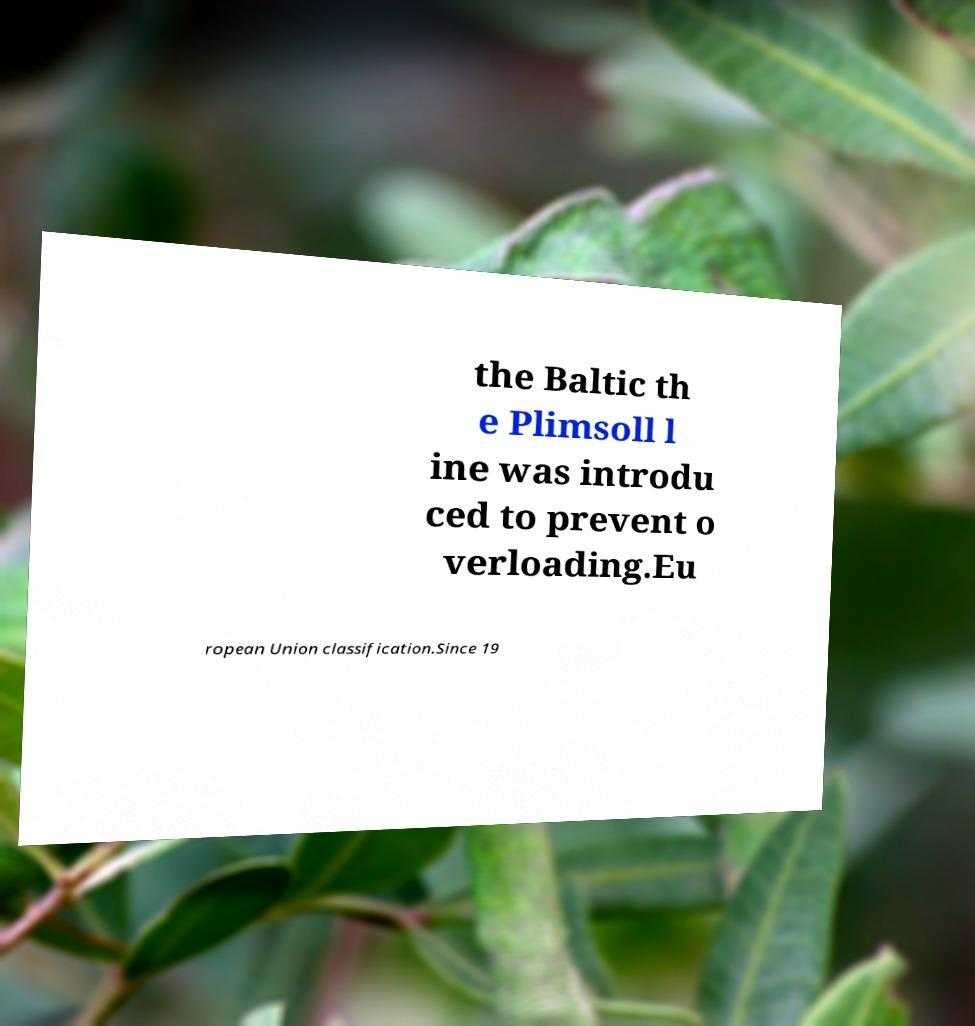There's text embedded in this image that I need extracted. Can you transcribe it verbatim? the Baltic th e Plimsoll l ine was introdu ced to prevent o verloading.Eu ropean Union classification.Since 19 